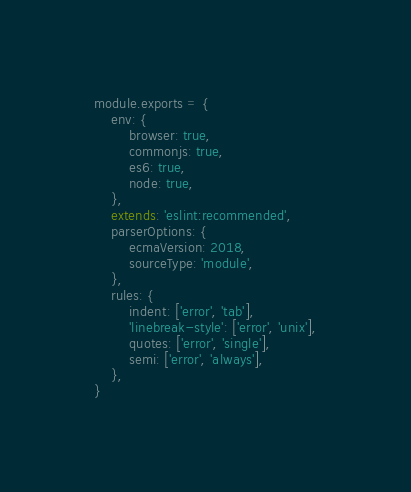<code> <loc_0><loc_0><loc_500><loc_500><_JavaScript_>module.exports = {
    env: {
        browser: true,
        commonjs: true,
        es6: true,
        node: true,
    },
    extends: 'eslint:recommended',
    parserOptions: {
        ecmaVersion: 2018,
        sourceType: 'module',
    },
    rules: {
        indent: ['error', 'tab'],
        'linebreak-style': ['error', 'unix'],
        quotes: ['error', 'single'],
        semi: ['error', 'always'],
    },
}
</code> 